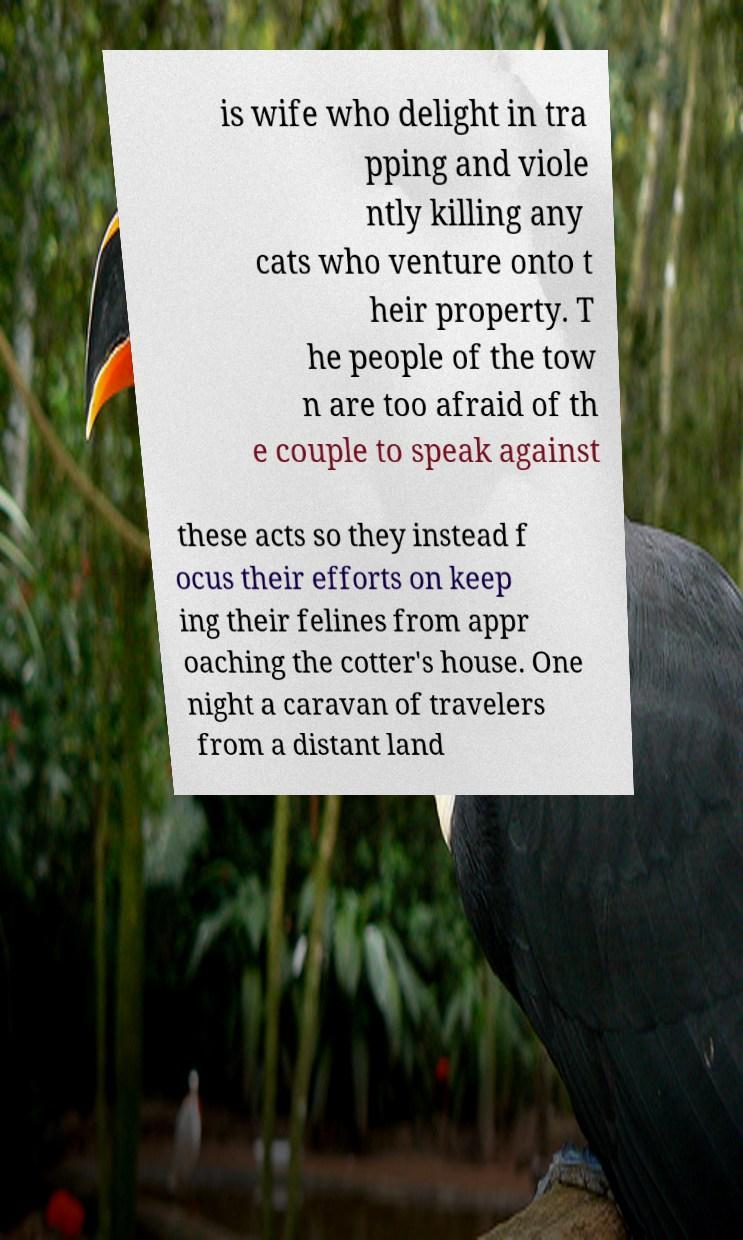Please read and relay the text visible in this image. What does it say? is wife who delight in tra pping and viole ntly killing any cats who venture onto t heir property. T he people of the tow n are too afraid of th e couple to speak against these acts so they instead f ocus their efforts on keep ing their felines from appr oaching the cotter's house. One night a caravan of travelers from a distant land 